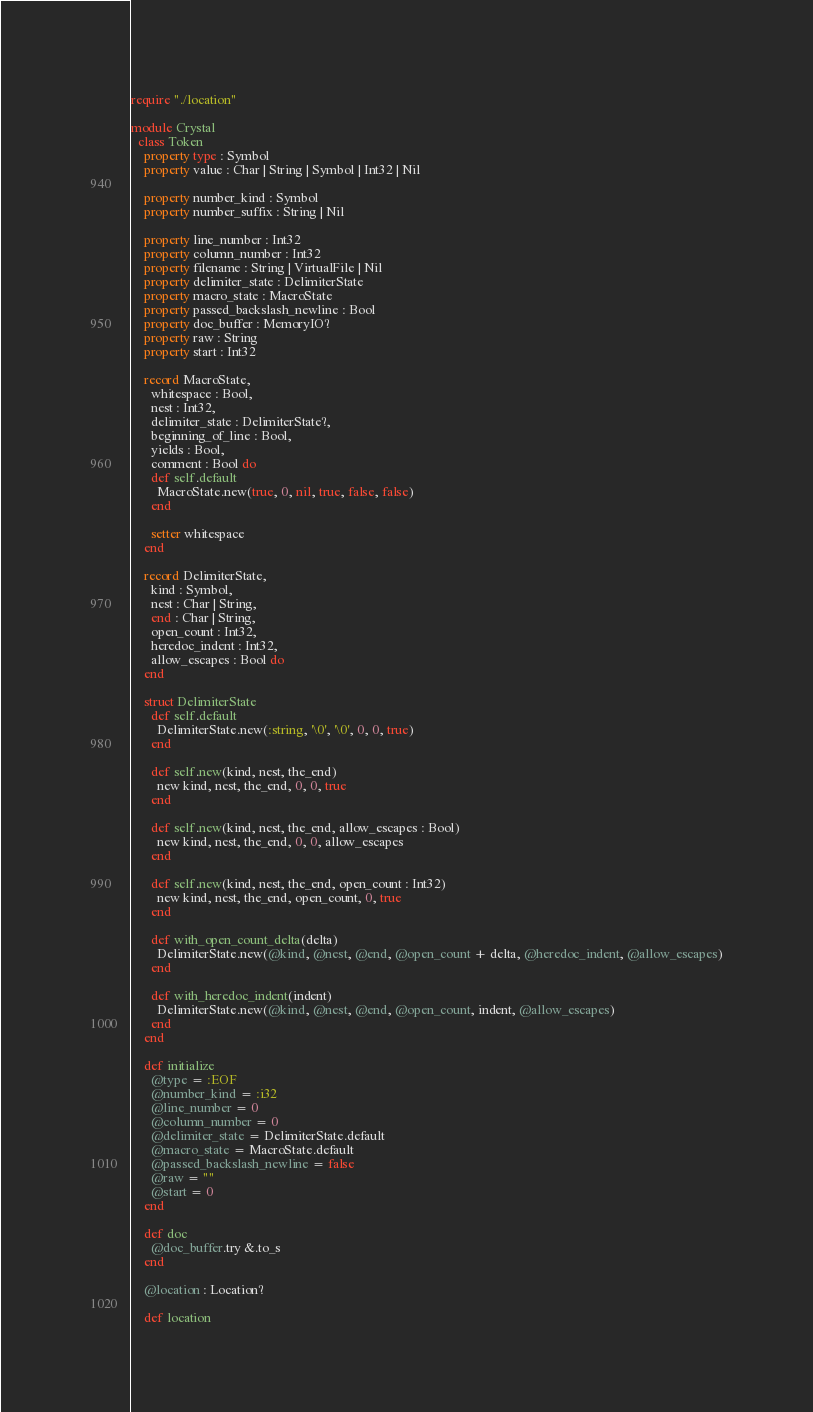<code> <loc_0><loc_0><loc_500><loc_500><_Crystal_>require "./location"

module Crystal
  class Token
    property type : Symbol
    property value : Char | String | Symbol | Int32 | Nil

    property number_kind : Symbol
    property number_suffix : String | Nil

    property line_number : Int32
    property column_number : Int32
    property filename : String | VirtualFile | Nil
    property delimiter_state : DelimiterState
    property macro_state : MacroState
    property passed_backslash_newline : Bool
    property doc_buffer : MemoryIO?
    property raw : String
    property start : Int32

    record MacroState,
      whitespace : Bool,
      nest : Int32,
      delimiter_state : DelimiterState?,
      beginning_of_line : Bool,
      yields : Bool,
      comment : Bool do
      def self.default
        MacroState.new(true, 0, nil, true, false, false)
      end

      setter whitespace
    end

    record DelimiterState,
      kind : Symbol,
      nest : Char | String,
      end : Char | String,
      open_count : Int32,
      heredoc_indent : Int32,
      allow_escapes : Bool do
    end

    struct DelimiterState
      def self.default
        DelimiterState.new(:string, '\0', '\0', 0, 0, true)
      end

      def self.new(kind, nest, the_end)
        new kind, nest, the_end, 0, 0, true
      end

      def self.new(kind, nest, the_end, allow_escapes : Bool)
        new kind, nest, the_end, 0, 0, allow_escapes
      end

      def self.new(kind, nest, the_end, open_count : Int32)
        new kind, nest, the_end, open_count, 0, true
      end

      def with_open_count_delta(delta)
        DelimiterState.new(@kind, @nest, @end, @open_count + delta, @heredoc_indent, @allow_escapes)
      end

      def with_heredoc_indent(indent)
        DelimiterState.new(@kind, @nest, @end, @open_count, indent, @allow_escapes)
      end
    end

    def initialize
      @type = :EOF
      @number_kind = :i32
      @line_number = 0
      @column_number = 0
      @delimiter_state = DelimiterState.default
      @macro_state = MacroState.default
      @passed_backslash_newline = false
      @raw = ""
      @start = 0
    end

    def doc
      @doc_buffer.try &.to_s
    end

    @location : Location?

    def location</code> 